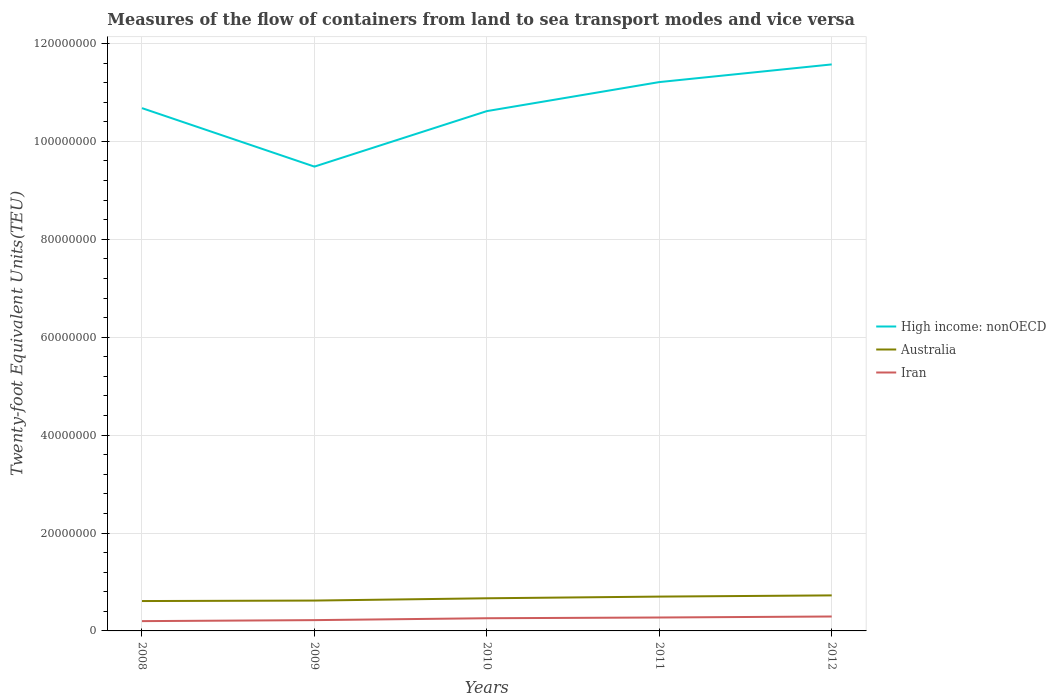How many different coloured lines are there?
Make the answer very short. 3. Does the line corresponding to Australia intersect with the line corresponding to High income: nonOECD?
Ensure brevity in your answer.  No. Across all years, what is the maximum container port traffic in Australia?
Give a very brief answer. 6.10e+06. In which year was the container port traffic in Australia maximum?
Offer a very short reply. 2008. What is the total container port traffic in Australia in the graph?
Offer a terse response. -1.16e+06. What is the difference between the highest and the second highest container port traffic in High income: nonOECD?
Keep it short and to the point. 2.09e+07. How many years are there in the graph?
Provide a succinct answer. 5. What is the difference between two consecutive major ticks on the Y-axis?
Provide a short and direct response. 2.00e+07. Does the graph contain grids?
Ensure brevity in your answer.  Yes. What is the title of the graph?
Provide a short and direct response. Measures of the flow of containers from land to sea transport modes and vice versa. Does "Sub-Saharan Africa (developing only)" appear as one of the legend labels in the graph?
Offer a very short reply. No. What is the label or title of the Y-axis?
Ensure brevity in your answer.  Twenty-foot Equivalent Units(TEU). What is the Twenty-foot Equivalent Units(TEU) in High income: nonOECD in 2008?
Provide a succinct answer. 1.07e+08. What is the Twenty-foot Equivalent Units(TEU) in Australia in 2008?
Your answer should be compact. 6.10e+06. What is the Twenty-foot Equivalent Units(TEU) of Iran in 2008?
Provide a succinct answer. 2.00e+06. What is the Twenty-foot Equivalent Units(TEU) in High income: nonOECD in 2009?
Keep it short and to the point. 9.48e+07. What is the Twenty-foot Equivalent Units(TEU) in Australia in 2009?
Make the answer very short. 6.20e+06. What is the Twenty-foot Equivalent Units(TEU) of Iran in 2009?
Give a very brief answer. 2.21e+06. What is the Twenty-foot Equivalent Units(TEU) of High income: nonOECD in 2010?
Keep it short and to the point. 1.06e+08. What is the Twenty-foot Equivalent Units(TEU) in Australia in 2010?
Provide a short and direct response. 6.67e+06. What is the Twenty-foot Equivalent Units(TEU) in Iran in 2010?
Make the answer very short. 2.59e+06. What is the Twenty-foot Equivalent Units(TEU) of High income: nonOECD in 2011?
Offer a very short reply. 1.12e+08. What is the Twenty-foot Equivalent Units(TEU) in Australia in 2011?
Your answer should be very brief. 7.01e+06. What is the Twenty-foot Equivalent Units(TEU) of Iran in 2011?
Your answer should be compact. 2.74e+06. What is the Twenty-foot Equivalent Units(TEU) of High income: nonOECD in 2012?
Give a very brief answer. 1.16e+08. What is the Twenty-foot Equivalent Units(TEU) of Australia in 2012?
Your answer should be very brief. 7.26e+06. What is the Twenty-foot Equivalent Units(TEU) of Iran in 2012?
Make the answer very short. 2.95e+06. Across all years, what is the maximum Twenty-foot Equivalent Units(TEU) of High income: nonOECD?
Provide a short and direct response. 1.16e+08. Across all years, what is the maximum Twenty-foot Equivalent Units(TEU) in Australia?
Provide a short and direct response. 7.26e+06. Across all years, what is the maximum Twenty-foot Equivalent Units(TEU) of Iran?
Give a very brief answer. 2.95e+06. Across all years, what is the minimum Twenty-foot Equivalent Units(TEU) of High income: nonOECD?
Keep it short and to the point. 9.48e+07. Across all years, what is the minimum Twenty-foot Equivalent Units(TEU) of Australia?
Ensure brevity in your answer.  6.10e+06. Across all years, what is the minimum Twenty-foot Equivalent Units(TEU) in Iran?
Your answer should be very brief. 2.00e+06. What is the total Twenty-foot Equivalent Units(TEU) of High income: nonOECD in the graph?
Offer a terse response. 5.36e+08. What is the total Twenty-foot Equivalent Units(TEU) of Australia in the graph?
Provide a short and direct response. 3.32e+07. What is the total Twenty-foot Equivalent Units(TEU) in Iran in the graph?
Provide a succinct answer. 1.25e+07. What is the difference between the Twenty-foot Equivalent Units(TEU) of High income: nonOECD in 2008 and that in 2009?
Provide a short and direct response. 1.19e+07. What is the difference between the Twenty-foot Equivalent Units(TEU) in Australia in 2008 and that in 2009?
Make the answer very short. -9.80e+04. What is the difference between the Twenty-foot Equivalent Units(TEU) of Iran in 2008 and that in 2009?
Ensure brevity in your answer.  -2.06e+05. What is the difference between the Twenty-foot Equivalent Units(TEU) of High income: nonOECD in 2008 and that in 2010?
Provide a succinct answer. 6.11e+05. What is the difference between the Twenty-foot Equivalent Units(TEU) of Australia in 2008 and that in 2010?
Your answer should be very brief. -5.66e+05. What is the difference between the Twenty-foot Equivalent Units(TEU) of Iran in 2008 and that in 2010?
Provide a succinct answer. -5.92e+05. What is the difference between the Twenty-foot Equivalent Units(TEU) in High income: nonOECD in 2008 and that in 2011?
Make the answer very short. -5.32e+06. What is the difference between the Twenty-foot Equivalent Units(TEU) in Australia in 2008 and that in 2011?
Ensure brevity in your answer.  -9.09e+05. What is the difference between the Twenty-foot Equivalent Units(TEU) in Iran in 2008 and that in 2011?
Your answer should be very brief. -7.40e+05. What is the difference between the Twenty-foot Equivalent Units(TEU) in High income: nonOECD in 2008 and that in 2012?
Your answer should be compact. -8.93e+06. What is the difference between the Twenty-foot Equivalent Units(TEU) in Australia in 2008 and that in 2012?
Make the answer very short. -1.16e+06. What is the difference between the Twenty-foot Equivalent Units(TEU) in Iran in 2008 and that in 2012?
Ensure brevity in your answer.  -9.46e+05. What is the difference between the Twenty-foot Equivalent Units(TEU) in High income: nonOECD in 2009 and that in 2010?
Your answer should be compact. -1.13e+07. What is the difference between the Twenty-foot Equivalent Units(TEU) of Australia in 2009 and that in 2010?
Ensure brevity in your answer.  -4.68e+05. What is the difference between the Twenty-foot Equivalent Units(TEU) of Iran in 2009 and that in 2010?
Offer a very short reply. -3.86e+05. What is the difference between the Twenty-foot Equivalent Units(TEU) in High income: nonOECD in 2009 and that in 2011?
Provide a short and direct response. -1.73e+07. What is the difference between the Twenty-foot Equivalent Units(TEU) of Australia in 2009 and that in 2011?
Keep it short and to the point. -8.11e+05. What is the difference between the Twenty-foot Equivalent Units(TEU) in Iran in 2009 and that in 2011?
Your answer should be compact. -5.34e+05. What is the difference between the Twenty-foot Equivalent Units(TEU) in High income: nonOECD in 2009 and that in 2012?
Make the answer very short. -2.09e+07. What is the difference between the Twenty-foot Equivalent Units(TEU) of Australia in 2009 and that in 2012?
Give a very brief answer. -1.06e+06. What is the difference between the Twenty-foot Equivalent Units(TEU) in Iran in 2009 and that in 2012?
Give a very brief answer. -7.39e+05. What is the difference between the Twenty-foot Equivalent Units(TEU) in High income: nonOECD in 2010 and that in 2011?
Give a very brief answer. -5.93e+06. What is the difference between the Twenty-foot Equivalent Units(TEU) of Australia in 2010 and that in 2011?
Your answer should be very brief. -3.44e+05. What is the difference between the Twenty-foot Equivalent Units(TEU) in Iran in 2010 and that in 2011?
Keep it short and to the point. -1.48e+05. What is the difference between the Twenty-foot Equivalent Units(TEU) in High income: nonOECD in 2010 and that in 2012?
Offer a terse response. -9.54e+06. What is the difference between the Twenty-foot Equivalent Units(TEU) of Australia in 2010 and that in 2012?
Your answer should be compact. -5.91e+05. What is the difference between the Twenty-foot Equivalent Units(TEU) of Iran in 2010 and that in 2012?
Keep it short and to the point. -3.53e+05. What is the difference between the Twenty-foot Equivalent Units(TEU) in High income: nonOECD in 2011 and that in 2012?
Provide a succinct answer. -3.61e+06. What is the difference between the Twenty-foot Equivalent Units(TEU) in Australia in 2011 and that in 2012?
Your response must be concise. -2.47e+05. What is the difference between the Twenty-foot Equivalent Units(TEU) in Iran in 2011 and that in 2012?
Offer a terse response. -2.06e+05. What is the difference between the Twenty-foot Equivalent Units(TEU) of High income: nonOECD in 2008 and the Twenty-foot Equivalent Units(TEU) of Australia in 2009?
Your answer should be very brief. 1.01e+08. What is the difference between the Twenty-foot Equivalent Units(TEU) in High income: nonOECD in 2008 and the Twenty-foot Equivalent Units(TEU) in Iran in 2009?
Your answer should be very brief. 1.05e+08. What is the difference between the Twenty-foot Equivalent Units(TEU) of Australia in 2008 and the Twenty-foot Equivalent Units(TEU) of Iran in 2009?
Offer a very short reply. 3.90e+06. What is the difference between the Twenty-foot Equivalent Units(TEU) in High income: nonOECD in 2008 and the Twenty-foot Equivalent Units(TEU) in Australia in 2010?
Offer a terse response. 1.00e+08. What is the difference between the Twenty-foot Equivalent Units(TEU) of High income: nonOECD in 2008 and the Twenty-foot Equivalent Units(TEU) of Iran in 2010?
Your answer should be compact. 1.04e+08. What is the difference between the Twenty-foot Equivalent Units(TEU) in Australia in 2008 and the Twenty-foot Equivalent Units(TEU) in Iran in 2010?
Your answer should be very brief. 3.51e+06. What is the difference between the Twenty-foot Equivalent Units(TEU) in High income: nonOECD in 2008 and the Twenty-foot Equivalent Units(TEU) in Australia in 2011?
Offer a very short reply. 9.98e+07. What is the difference between the Twenty-foot Equivalent Units(TEU) of High income: nonOECD in 2008 and the Twenty-foot Equivalent Units(TEU) of Iran in 2011?
Give a very brief answer. 1.04e+08. What is the difference between the Twenty-foot Equivalent Units(TEU) in Australia in 2008 and the Twenty-foot Equivalent Units(TEU) in Iran in 2011?
Give a very brief answer. 3.36e+06. What is the difference between the Twenty-foot Equivalent Units(TEU) of High income: nonOECD in 2008 and the Twenty-foot Equivalent Units(TEU) of Australia in 2012?
Ensure brevity in your answer.  9.95e+07. What is the difference between the Twenty-foot Equivalent Units(TEU) in High income: nonOECD in 2008 and the Twenty-foot Equivalent Units(TEU) in Iran in 2012?
Keep it short and to the point. 1.04e+08. What is the difference between the Twenty-foot Equivalent Units(TEU) in Australia in 2008 and the Twenty-foot Equivalent Units(TEU) in Iran in 2012?
Offer a terse response. 3.16e+06. What is the difference between the Twenty-foot Equivalent Units(TEU) of High income: nonOECD in 2009 and the Twenty-foot Equivalent Units(TEU) of Australia in 2010?
Your response must be concise. 8.82e+07. What is the difference between the Twenty-foot Equivalent Units(TEU) of High income: nonOECD in 2009 and the Twenty-foot Equivalent Units(TEU) of Iran in 2010?
Give a very brief answer. 9.22e+07. What is the difference between the Twenty-foot Equivalent Units(TEU) in Australia in 2009 and the Twenty-foot Equivalent Units(TEU) in Iran in 2010?
Your response must be concise. 3.61e+06. What is the difference between the Twenty-foot Equivalent Units(TEU) in High income: nonOECD in 2009 and the Twenty-foot Equivalent Units(TEU) in Australia in 2011?
Your answer should be very brief. 8.78e+07. What is the difference between the Twenty-foot Equivalent Units(TEU) in High income: nonOECD in 2009 and the Twenty-foot Equivalent Units(TEU) in Iran in 2011?
Offer a terse response. 9.21e+07. What is the difference between the Twenty-foot Equivalent Units(TEU) in Australia in 2009 and the Twenty-foot Equivalent Units(TEU) in Iran in 2011?
Give a very brief answer. 3.46e+06. What is the difference between the Twenty-foot Equivalent Units(TEU) of High income: nonOECD in 2009 and the Twenty-foot Equivalent Units(TEU) of Australia in 2012?
Offer a terse response. 8.76e+07. What is the difference between the Twenty-foot Equivalent Units(TEU) in High income: nonOECD in 2009 and the Twenty-foot Equivalent Units(TEU) in Iran in 2012?
Your response must be concise. 9.19e+07. What is the difference between the Twenty-foot Equivalent Units(TEU) of Australia in 2009 and the Twenty-foot Equivalent Units(TEU) of Iran in 2012?
Keep it short and to the point. 3.25e+06. What is the difference between the Twenty-foot Equivalent Units(TEU) in High income: nonOECD in 2010 and the Twenty-foot Equivalent Units(TEU) in Australia in 2011?
Offer a terse response. 9.92e+07. What is the difference between the Twenty-foot Equivalent Units(TEU) in High income: nonOECD in 2010 and the Twenty-foot Equivalent Units(TEU) in Iran in 2011?
Your answer should be very brief. 1.03e+08. What is the difference between the Twenty-foot Equivalent Units(TEU) in Australia in 2010 and the Twenty-foot Equivalent Units(TEU) in Iran in 2011?
Your response must be concise. 3.93e+06. What is the difference between the Twenty-foot Equivalent Units(TEU) of High income: nonOECD in 2010 and the Twenty-foot Equivalent Units(TEU) of Australia in 2012?
Provide a succinct answer. 9.89e+07. What is the difference between the Twenty-foot Equivalent Units(TEU) of High income: nonOECD in 2010 and the Twenty-foot Equivalent Units(TEU) of Iran in 2012?
Make the answer very short. 1.03e+08. What is the difference between the Twenty-foot Equivalent Units(TEU) of Australia in 2010 and the Twenty-foot Equivalent Units(TEU) of Iran in 2012?
Your response must be concise. 3.72e+06. What is the difference between the Twenty-foot Equivalent Units(TEU) of High income: nonOECD in 2011 and the Twenty-foot Equivalent Units(TEU) of Australia in 2012?
Offer a terse response. 1.05e+08. What is the difference between the Twenty-foot Equivalent Units(TEU) in High income: nonOECD in 2011 and the Twenty-foot Equivalent Units(TEU) in Iran in 2012?
Keep it short and to the point. 1.09e+08. What is the difference between the Twenty-foot Equivalent Units(TEU) in Australia in 2011 and the Twenty-foot Equivalent Units(TEU) in Iran in 2012?
Offer a terse response. 4.07e+06. What is the average Twenty-foot Equivalent Units(TEU) of High income: nonOECD per year?
Make the answer very short. 1.07e+08. What is the average Twenty-foot Equivalent Units(TEU) in Australia per year?
Make the answer very short. 6.65e+06. What is the average Twenty-foot Equivalent Units(TEU) in Iran per year?
Offer a terse response. 2.50e+06. In the year 2008, what is the difference between the Twenty-foot Equivalent Units(TEU) in High income: nonOECD and Twenty-foot Equivalent Units(TEU) in Australia?
Keep it short and to the point. 1.01e+08. In the year 2008, what is the difference between the Twenty-foot Equivalent Units(TEU) in High income: nonOECD and Twenty-foot Equivalent Units(TEU) in Iran?
Provide a short and direct response. 1.05e+08. In the year 2008, what is the difference between the Twenty-foot Equivalent Units(TEU) of Australia and Twenty-foot Equivalent Units(TEU) of Iran?
Your answer should be compact. 4.10e+06. In the year 2009, what is the difference between the Twenty-foot Equivalent Units(TEU) in High income: nonOECD and Twenty-foot Equivalent Units(TEU) in Australia?
Provide a succinct answer. 8.86e+07. In the year 2009, what is the difference between the Twenty-foot Equivalent Units(TEU) in High income: nonOECD and Twenty-foot Equivalent Units(TEU) in Iran?
Offer a terse response. 9.26e+07. In the year 2009, what is the difference between the Twenty-foot Equivalent Units(TEU) in Australia and Twenty-foot Equivalent Units(TEU) in Iran?
Give a very brief answer. 3.99e+06. In the year 2010, what is the difference between the Twenty-foot Equivalent Units(TEU) of High income: nonOECD and Twenty-foot Equivalent Units(TEU) of Australia?
Keep it short and to the point. 9.95e+07. In the year 2010, what is the difference between the Twenty-foot Equivalent Units(TEU) in High income: nonOECD and Twenty-foot Equivalent Units(TEU) in Iran?
Keep it short and to the point. 1.04e+08. In the year 2010, what is the difference between the Twenty-foot Equivalent Units(TEU) of Australia and Twenty-foot Equivalent Units(TEU) of Iran?
Provide a succinct answer. 4.08e+06. In the year 2011, what is the difference between the Twenty-foot Equivalent Units(TEU) in High income: nonOECD and Twenty-foot Equivalent Units(TEU) in Australia?
Provide a short and direct response. 1.05e+08. In the year 2011, what is the difference between the Twenty-foot Equivalent Units(TEU) of High income: nonOECD and Twenty-foot Equivalent Units(TEU) of Iran?
Your answer should be very brief. 1.09e+08. In the year 2011, what is the difference between the Twenty-foot Equivalent Units(TEU) of Australia and Twenty-foot Equivalent Units(TEU) of Iran?
Your answer should be compact. 4.27e+06. In the year 2012, what is the difference between the Twenty-foot Equivalent Units(TEU) in High income: nonOECD and Twenty-foot Equivalent Units(TEU) in Australia?
Offer a very short reply. 1.08e+08. In the year 2012, what is the difference between the Twenty-foot Equivalent Units(TEU) in High income: nonOECD and Twenty-foot Equivalent Units(TEU) in Iran?
Give a very brief answer. 1.13e+08. In the year 2012, what is the difference between the Twenty-foot Equivalent Units(TEU) in Australia and Twenty-foot Equivalent Units(TEU) in Iran?
Ensure brevity in your answer.  4.31e+06. What is the ratio of the Twenty-foot Equivalent Units(TEU) of High income: nonOECD in 2008 to that in 2009?
Your response must be concise. 1.13. What is the ratio of the Twenty-foot Equivalent Units(TEU) in Australia in 2008 to that in 2009?
Make the answer very short. 0.98. What is the ratio of the Twenty-foot Equivalent Units(TEU) in Iran in 2008 to that in 2009?
Keep it short and to the point. 0.91. What is the ratio of the Twenty-foot Equivalent Units(TEU) in High income: nonOECD in 2008 to that in 2010?
Make the answer very short. 1.01. What is the ratio of the Twenty-foot Equivalent Units(TEU) of Australia in 2008 to that in 2010?
Your answer should be compact. 0.92. What is the ratio of the Twenty-foot Equivalent Units(TEU) of Iran in 2008 to that in 2010?
Give a very brief answer. 0.77. What is the ratio of the Twenty-foot Equivalent Units(TEU) in High income: nonOECD in 2008 to that in 2011?
Offer a terse response. 0.95. What is the ratio of the Twenty-foot Equivalent Units(TEU) in Australia in 2008 to that in 2011?
Give a very brief answer. 0.87. What is the ratio of the Twenty-foot Equivalent Units(TEU) in Iran in 2008 to that in 2011?
Make the answer very short. 0.73. What is the ratio of the Twenty-foot Equivalent Units(TEU) in High income: nonOECD in 2008 to that in 2012?
Your response must be concise. 0.92. What is the ratio of the Twenty-foot Equivalent Units(TEU) in Australia in 2008 to that in 2012?
Ensure brevity in your answer.  0.84. What is the ratio of the Twenty-foot Equivalent Units(TEU) of Iran in 2008 to that in 2012?
Provide a succinct answer. 0.68. What is the ratio of the Twenty-foot Equivalent Units(TEU) in High income: nonOECD in 2009 to that in 2010?
Offer a terse response. 0.89. What is the ratio of the Twenty-foot Equivalent Units(TEU) of Australia in 2009 to that in 2010?
Keep it short and to the point. 0.93. What is the ratio of the Twenty-foot Equivalent Units(TEU) in Iran in 2009 to that in 2010?
Keep it short and to the point. 0.85. What is the ratio of the Twenty-foot Equivalent Units(TEU) in High income: nonOECD in 2009 to that in 2011?
Ensure brevity in your answer.  0.85. What is the ratio of the Twenty-foot Equivalent Units(TEU) of Australia in 2009 to that in 2011?
Provide a succinct answer. 0.88. What is the ratio of the Twenty-foot Equivalent Units(TEU) in Iran in 2009 to that in 2011?
Give a very brief answer. 0.81. What is the ratio of the Twenty-foot Equivalent Units(TEU) of High income: nonOECD in 2009 to that in 2012?
Your response must be concise. 0.82. What is the ratio of the Twenty-foot Equivalent Units(TEU) in Australia in 2009 to that in 2012?
Provide a succinct answer. 0.85. What is the ratio of the Twenty-foot Equivalent Units(TEU) in Iran in 2009 to that in 2012?
Provide a short and direct response. 0.75. What is the ratio of the Twenty-foot Equivalent Units(TEU) of High income: nonOECD in 2010 to that in 2011?
Ensure brevity in your answer.  0.95. What is the ratio of the Twenty-foot Equivalent Units(TEU) of Australia in 2010 to that in 2011?
Ensure brevity in your answer.  0.95. What is the ratio of the Twenty-foot Equivalent Units(TEU) of Iran in 2010 to that in 2011?
Your response must be concise. 0.95. What is the ratio of the Twenty-foot Equivalent Units(TEU) in High income: nonOECD in 2010 to that in 2012?
Ensure brevity in your answer.  0.92. What is the ratio of the Twenty-foot Equivalent Units(TEU) of Australia in 2010 to that in 2012?
Offer a terse response. 0.92. What is the ratio of the Twenty-foot Equivalent Units(TEU) of Iran in 2010 to that in 2012?
Make the answer very short. 0.88. What is the ratio of the Twenty-foot Equivalent Units(TEU) of High income: nonOECD in 2011 to that in 2012?
Your answer should be very brief. 0.97. What is the ratio of the Twenty-foot Equivalent Units(TEU) of Australia in 2011 to that in 2012?
Your answer should be compact. 0.97. What is the ratio of the Twenty-foot Equivalent Units(TEU) of Iran in 2011 to that in 2012?
Your answer should be compact. 0.93. What is the difference between the highest and the second highest Twenty-foot Equivalent Units(TEU) of High income: nonOECD?
Provide a short and direct response. 3.61e+06. What is the difference between the highest and the second highest Twenty-foot Equivalent Units(TEU) of Australia?
Offer a very short reply. 2.47e+05. What is the difference between the highest and the second highest Twenty-foot Equivalent Units(TEU) of Iran?
Give a very brief answer. 2.06e+05. What is the difference between the highest and the lowest Twenty-foot Equivalent Units(TEU) in High income: nonOECD?
Your answer should be very brief. 2.09e+07. What is the difference between the highest and the lowest Twenty-foot Equivalent Units(TEU) in Australia?
Give a very brief answer. 1.16e+06. What is the difference between the highest and the lowest Twenty-foot Equivalent Units(TEU) of Iran?
Keep it short and to the point. 9.46e+05. 